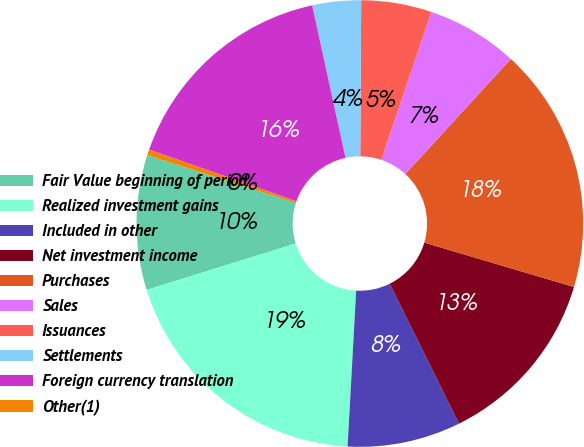<chart> <loc_0><loc_0><loc_500><loc_500><pie_chart><fcel>Fair Value beginning of period<fcel>Realized investment gains<fcel>Included in other<fcel>Net investment income<fcel>Purchases<fcel>Sales<fcel>Issuances<fcel>Settlements<fcel>Foreign currency translation<fcel>Other(1)<nl><fcel>9.76%<fcel>19.32%<fcel>8.2%<fcel>13.09%<fcel>17.77%<fcel>6.64%<fcel>5.08%<fcel>3.52%<fcel>16.21%<fcel>0.41%<nl></chart> 